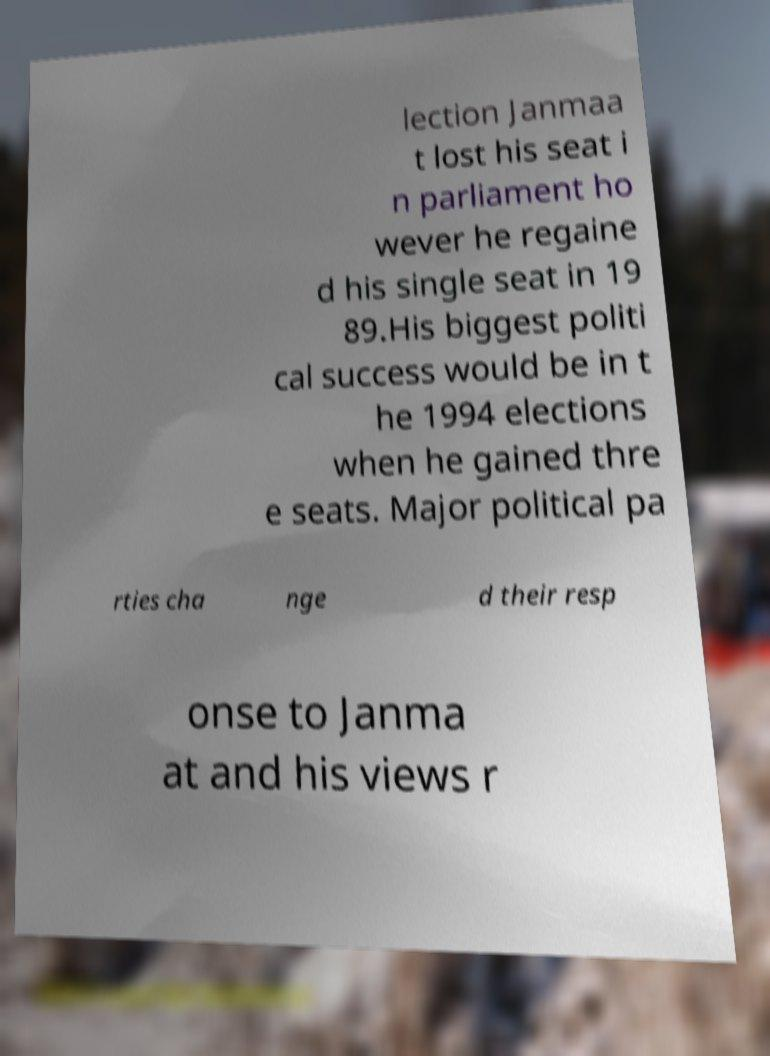Could you assist in decoding the text presented in this image and type it out clearly? lection Janmaa t lost his seat i n parliament ho wever he regaine d his single seat in 19 89.His biggest politi cal success would be in t he 1994 elections when he gained thre e seats. Major political pa rties cha nge d their resp onse to Janma at and his views r 